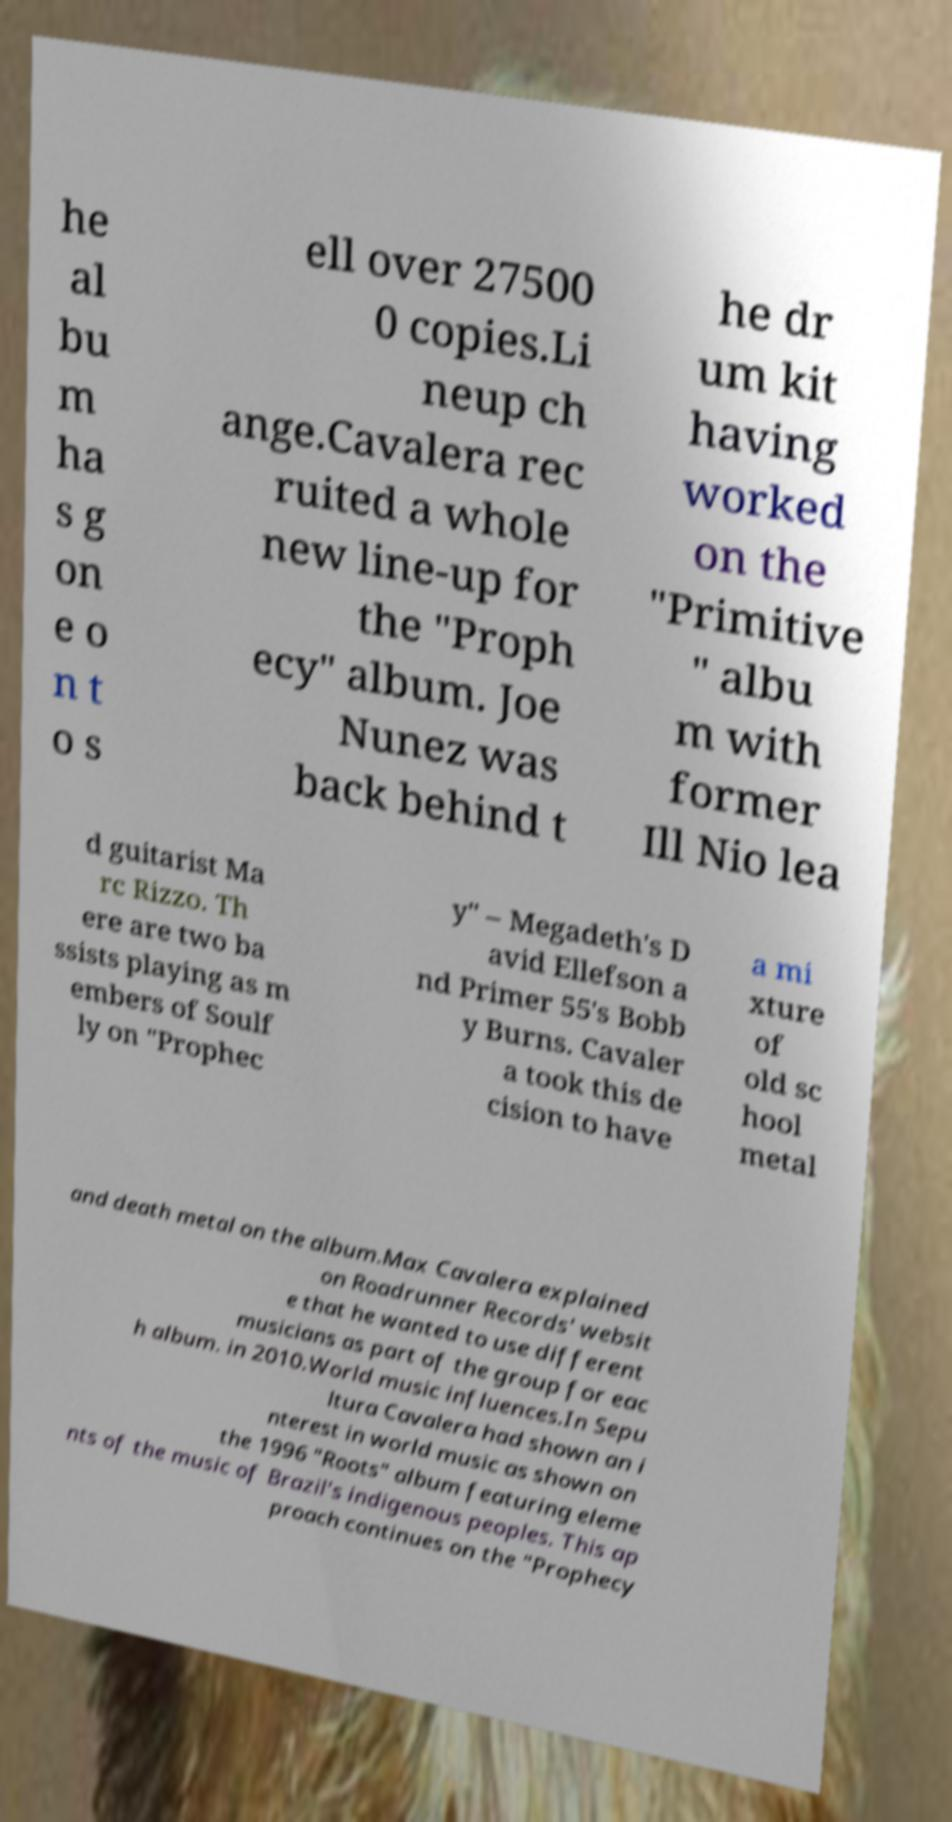There's text embedded in this image that I need extracted. Can you transcribe it verbatim? he al bu m ha s g on e o n t o s ell over 27500 0 copies.Li neup ch ange.Cavalera rec ruited a whole new line-up for the "Proph ecy" album. Joe Nunez was back behind t he dr um kit having worked on the "Primitive " albu m with former Ill Nio lea d guitarist Ma rc Rizzo. Th ere are two ba ssists playing as m embers of Soulf ly on "Prophec y" – Megadeth's D avid Ellefson a nd Primer 55's Bobb y Burns. Cavaler a took this de cision to have a mi xture of old sc hool metal and death metal on the album.Max Cavalera explained on Roadrunner Records' websit e that he wanted to use different musicians as part of the group for eac h album. in 2010.World music influences.In Sepu ltura Cavalera had shown an i nterest in world music as shown on the 1996 "Roots" album featuring eleme nts of the music of Brazil's indigenous peoples. This ap proach continues on the "Prophecy 